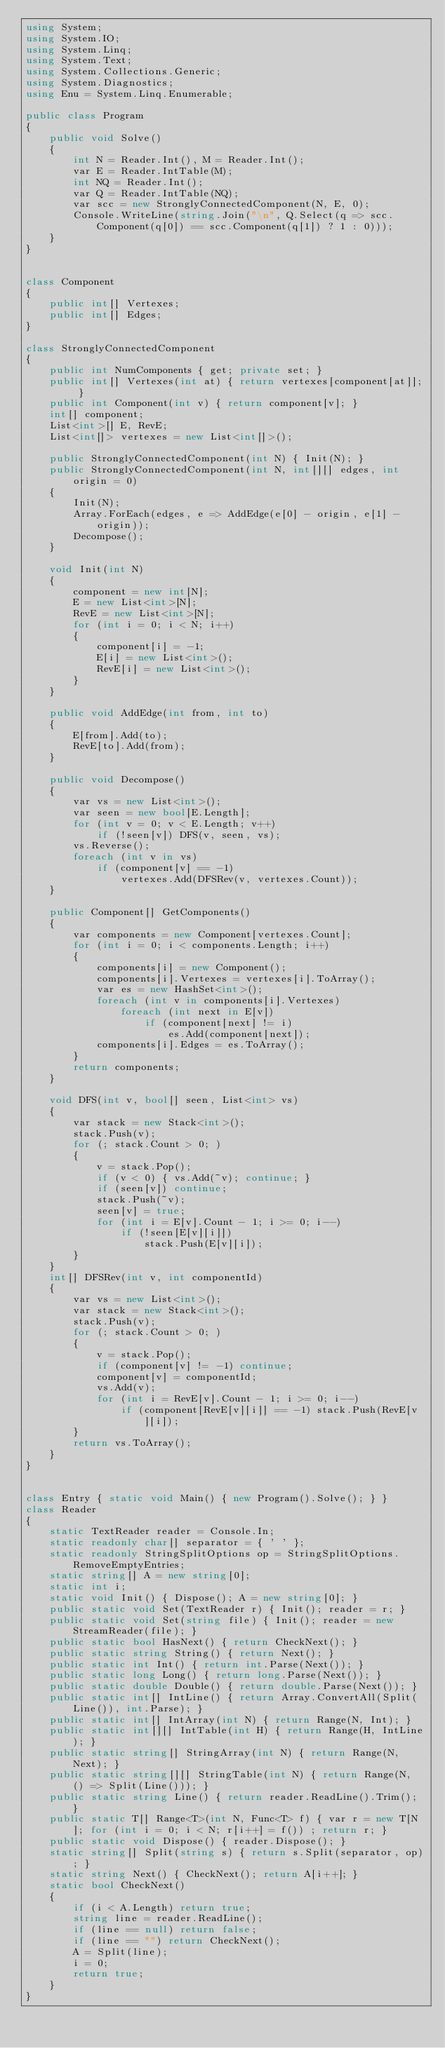<code> <loc_0><loc_0><loc_500><loc_500><_C#_>using System;
using System.IO;
using System.Linq;
using System.Text;
using System.Collections.Generic;
using System.Diagnostics;
using Enu = System.Linq.Enumerable;

public class Program
{
    public void Solve()
    {
        int N = Reader.Int(), M = Reader.Int();
        var E = Reader.IntTable(M);
        int NQ = Reader.Int();
        var Q = Reader.IntTable(NQ);
        var scc = new StronglyConnectedComponent(N, E, 0);
        Console.WriteLine(string.Join("\n", Q.Select(q => scc.Component(q[0]) == scc.Component(q[1]) ? 1 : 0)));
    }
}


class Component
{
    public int[] Vertexes;
    public int[] Edges;
}

class StronglyConnectedComponent
{
    public int NumComponents { get; private set; }
    public int[] Vertexes(int at) { return vertexes[component[at]]; }
    public int Component(int v) { return component[v]; }
    int[] component;
    List<int>[] E, RevE;
    List<int[]> vertexes = new List<int[]>();

    public StronglyConnectedComponent(int N) { Init(N); }
    public StronglyConnectedComponent(int N, int[][] edges, int origin = 0)
    {
        Init(N);
        Array.ForEach(edges, e => AddEdge(e[0] - origin, e[1] - origin));
        Decompose();
    }

    void Init(int N)
    {
        component = new int[N];
        E = new List<int>[N];
        RevE = new List<int>[N];
        for (int i = 0; i < N; i++)
        {
            component[i] = -1;
            E[i] = new List<int>();
            RevE[i] = new List<int>();
        }
    }

    public void AddEdge(int from, int to)
    {
        E[from].Add(to);
        RevE[to].Add(from);
    }

    public void Decompose()
    {
        var vs = new List<int>();
        var seen = new bool[E.Length];
        for (int v = 0; v < E.Length; v++)
            if (!seen[v]) DFS(v, seen, vs);
        vs.Reverse();
        foreach (int v in vs)
            if (component[v] == -1)
                vertexes.Add(DFSRev(v, vertexes.Count));
    }

    public Component[] GetComponents()
    {
        var components = new Component[vertexes.Count];
        for (int i = 0; i < components.Length; i++)
        {
            components[i] = new Component();
            components[i].Vertexes = vertexes[i].ToArray();
            var es = new HashSet<int>();
            foreach (int v in components[i].Vertexes)
                foreach (int next in E[v])
                    if (component[next] != i)
                        es.Add(component[next]);
            components[i].Edges = es.ToArray();
        }
        return components;
    }

    void DFS(int v, bool[] seen, List<int> vs)
    {
        var stack = new Stack<int>();
        stack.Push(v);
        for (; stack.Count > 0; )
        {
            v = stack.Pop();
            if (v < 0) { vs.Add(~v); continue; }
            if (seen[v]) continue;
            stack.Push(~v);
            seen[v] = true;
            for (int i = E[v].Count - 1; i >= 0; i--)
                if (!seen[E[v][i]])
                    stack.Push(E[v][i]);
        }
    }
    int[] DFSRev(int v, int componentId)
    {
        var vs = new List<int>();
        var stack = new Stack<int>();
        stack.Push(v);
        for (; stack.Count > 0; )
        {
            v = stack.Pop();
            if (component[v] != -1) continue;
            component[v] = componentId;
            vs.Add(v);
            for (int i = RevE[v].Count - 1; i >= 0; i--)
                if (component[RevE[v][i]] == -1) stack.Push(RevE[v][i]);
        }
        return vs.ToArray();
    }
}


class Entry { static void Main() { new Program().Solve(); } }
class Reader
{
    static TextReader reader = Console.In;
    static readonly char[] separator = { ' ' };
    static readonly StringSplitOptions op = StringSplitOptions.RemoveEmptyEntries;
    static string[] A = new string[0];
    static int i;
    static void Init() { Dispose(); A = new string[0]; }
    public static void Set(TextReader r) { Init(); reader = r; }
    public static void Set(string file) { Init(); reader = new StreamReader(file); }
    public static bool HasNext() { return CheckNext(); }
    public static string String() { return Next(); }
    public static int Int() { return int.Parse(Next()); }
    public static long Long() { return long.Parse(Next()); }
    public static double Double() { return double.Parse(Next()); }
    public static int[] IntLine() { return Array.ConvertAll(Split(Line()), int.Parse); }
    public static int[] IntArray(int N) { return Range(N, Int); }
    public static int[][] IntTable(int H) { return Range(H, IntLine); }
    public static string[] StringArray(int N) { return Range(N, Next); }
    public static string[][] StringTable(int N) { return Range(N, () => Split(Line())); }
    public static string Line() { return reader.ReadLine().Trim(); }
    public static T[] Range<T>(int N, Func<T> f) { var r = new T[N]; for (int i = 0; i < N; r[i++] = f()) ; return r; }
    public static void Dispose() { reader.Dispose(); }
    static string[] Split(string s) { return s.Split(separator, op); }
    static string Next() { CheckNext(); return A[i++]; }
    static bool CheckNext()
    {
        if (i < A.Length) return true;
        string line = reader.ReadLine();
        if (line == null) return false;
        if (line == "") return CheckNext();
        A = Split(line);
        i = 0;
        return true;
    }
}</code> 